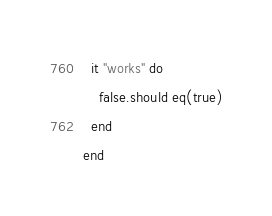Convert code to text. <code><loc_0><loc_0><loc_500><loc_500><_Crystal_>
  it "works" do
    false.should eq(true)
  end
end
</code> 